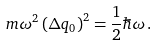<formula> <loc_0><loc_0><loc_500><loc_500>m \omega ^ { 2 } \left ( \Delta q _ { 0 } \right ) ^ { 2 } = \frac { 1 } { 2 } \hbar { \omega } \, .</formula> 